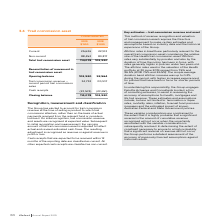According to Iselect's financial document, Which cash receipts are classified as current? Cash receipts that are expected to be received within 12 months of the reporting date. The document states: "Cash receipts that are expected to be received within 12 months of the reporting date are classified as current. All other expected cash receipts are ..." Also, What is the range of the attrition rates used in the valuation of the Health portfolio at 30 June 2019? According to the financial document, 7.5% and 26.5%. The relevant text states: "f the Health portfolio at 30 June 2019 ranged from 7.5% and 26.5% (2018: 7.5% and 26.5%). The simple average duration band attrition increase was up to 0.2% during th f the Health portfolio at 30 June..." Also, What was the increase in the average duration band attrition in 2019? According to the financial document, up to 0.2%. The relevant text states: "imple average duration band attrition increase was up to 0.2% during the period, with higher increases experienced for policies that have been in force for shorte..." Also, can you calculate: What is the percentage change in the current trail commission asset from 2018 to 2019? To answer this question, I need to perform calculations using the financial data. The calculation is: (25,626-22,103)/22,103, which equals 15.94 (percentage). This is based on the information: "Current 25,626 22,103 Current 25,626 22,103..." The key data points involved are: 22,103, 25,626. Also, can you calculate: What is the percentage change in the total trail commission asset from 2018 to 2019? To answer this question, I need to perform calculations using the financial data. The calculation is: (114,078-102,920)/102,920, which equals 10.84 (percentage). This is based on the information: "Total trail commission asset 114,078 102,920 Total trail commission asset 114,078 102,920..." The key data points involved are: 102,920, 114,078. Also, can you calculate: What is the percentage change in the cash receipts from 2018 to 2019? To answer this question, I need to perform calculations using the financial data. The calculation is: (23,574-23,651)/23,651, which equals -0.33 (percentage). This is based on the information: "Cash receipts (23,574) (23,651) Cash receipts (23,574) (23,651)..." The key data points involved are: 23,574, 23,651. 